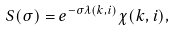Convert formula to latex. <formula><loc_0><loc_0><loc_500><loc_500>S ( \sigma ) = e ^ { - \sigma \lambda ( { k } , i ) } \chi ( { k } , i ) ,</formula> 